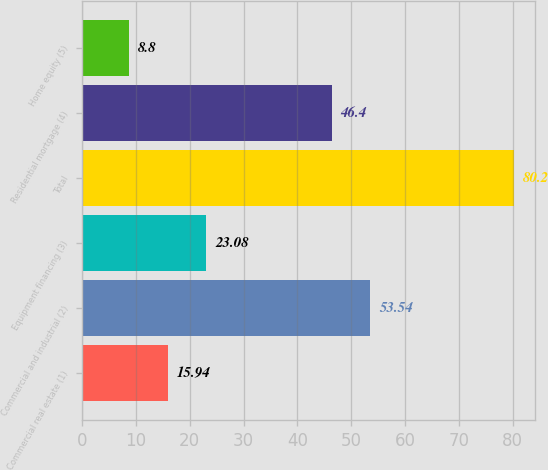<chart> <loc_0><loc_0><loc_500><loc_500><bar_chart><fcel>Commercial real estate (1)<fcel>Commercial and industrial (2)<fcel>Equipment financing (3)<fcel>Total<fcel>Residential mortgage (4)<fcel>Home equity (5)<nl><fcel>15.94<fcel>53.54<fcel>23.08<fcel>80.2<fcel>46.4<fcel>8.8<nl></chart> 